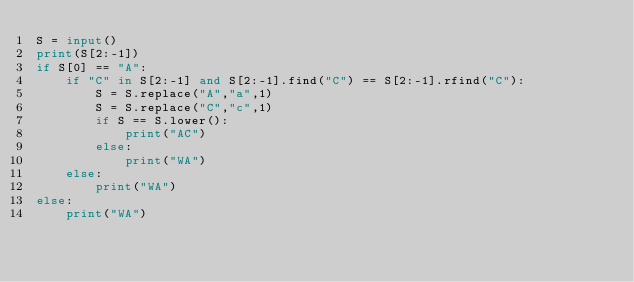Convert code to text. <code><loc_0><loc_0><loc_500><loc_500><_Python_>S = input()
print(S[2:-1])
if S[0] == "A":
    if "C" in S[2:-1] and S[2:-1].find("C") == S[2:-1].rfind("C"):
        S = S.replace("A","a",1)
        S = S.replace("C","c",1)
        if S == S.lower():
            print("AC")
        else:
            print("WA")
    else:
        print("WA")
else:
    print("WA")</code> 